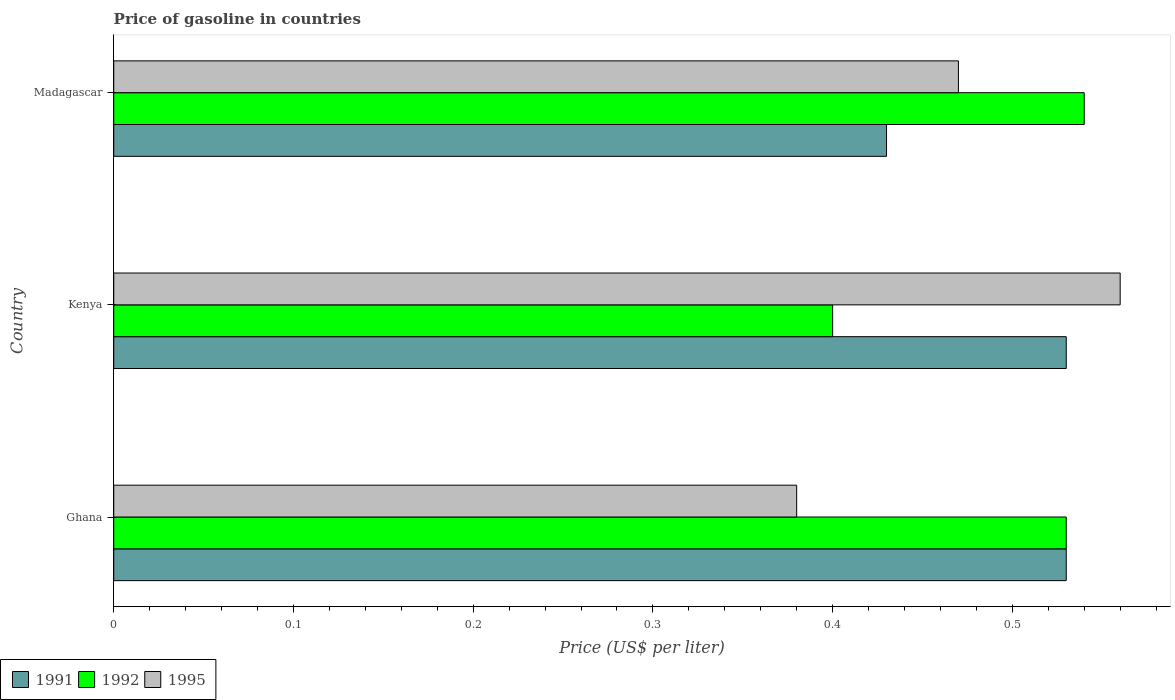Are the number of bars per tick equal to the number of legend labels?
Offer a very short reply. Yes. Are the number of bars on each tick of the Y-axis equal?
Make the answer very short. Yes. How many bars are there on the 2nd tick from the bottom?
Provide a short and direct response. 3. What is the label of the 3rd group of bars from the top?
Ensure brevity in your answer.  Ghana. In how many cases, is the number of bars for a given country not equal to the number of legend labels?
Offer a very short reply. 0. What is the price of gasoline in 1995 in Ghana?
Give a very brief answer. 0.38. Across all countries, what is the maximum price of gasoline in 1995?
Keep it short and to the point. 0.56. Across all countries, what is the minimum price of gasoline in 1992?
Your response must be concise. 0.4. In which country was the price of gasoline in 1991 maximum?
Provide a succinct answer. Ghana. What is the total price of gasoline in 1992 in the graph?
Provide a short and direct response. 1.47. What is the difference between the price of gasoline in 1995 in Ghana and that in Kenya?
Give a very brief answer. -0.18. What is the difference between the price of gasoline in 1995 in Ghana and the price of gasoline in 1991 in Madagascar?
Offer a very short reply. -0.05. What is the average price of gasoline in 1992 per country?
Ensure brevity in your answer.  0.49. What is the difference between the price of gasoline in 1992 and price of gasoline in 1995 in Madagascar?
Your response must be concise. 0.07. What is the ratio of the price of gasoline in 1995 in Ghana to that in Madagascar?
Ensure brevity in your answer.  0.81. Is the price of gasoline in 1991 in Ghana less than that in Madagascar?
Your answer should be very brief. No. What is the difference between the highest and the lowest price of gasoline in 1995?
Give a very brief answer. 0.18. Is the sum of the price of gasoline in 1991 in Ghana and Madagascar greater than the maximum price of gasoline in 1992 across all countries?
Keep it short and to the point. Yes. What does the 3rd bar from the bottom in Kenya represents?
Offer a terse response. 1995. Are all the bars in the graph horizontal?
Make the answer very short. Yes. How many countries are there in the graph?
Make the answer very short. 3. What is the difference between two consecutive major ticks on the X-axis?
Make the answer very short. 0.1. Are the values on the major ticks of X-axis written in scientific E-notation?
Provide a succinct answer. No. Does the graph contain grids?
Keep it short and to the point. No. How many legend labels are there?
Your answer should be very brief. 3. How are the legend labels stacked?
Give a very brief answer. Horizontal. What is the title of the graph?
Offer a terse response. Price of gasoline in countries. What is the label or title of the X-axis?
Your answer should be compact. Price (US$ per liter). What is the Price (US$ per liter) of 1991 in Ghana?
Ensure brevity in your answer.  0.53. What is the Price (US$ per liter) of 1992 in Ghana?
Make the answer very short. 0.53. What is the Price (US$ per liter) in 1995 in Ghana?
Keep it short and to the point. 0.38. What is the Price (US$ per liter) of 1991 in Kenya?
Provide a succinct answer. 0.53. What is the Price (US$ per liter) of 1992 in Kenya?
Your answer should be very brief. 0.4. What is the Price (US$ per liter) in 1995 in Kenya?
Your response must be concise. 0.56. What is the Price (US$ per liter) of 1991 in Madagascar?
Offer a very short reply. 0.43. What is the Price (US$ per liter) in 1992 in Madagascar?
Your answer should be very brief. 0.54. What is the Price (US$ per liter) of 1995 in Madagascar?
Your answer should be compact. 0.47. Across all countries, what is the maximum Price (US$ per liter) of 1991?
Your answer should be compact. 0.53. Across all countries, what is the maximum Price (US$ per liter) of 1992?
Make the answer very short. 0.54. Across all countries, what is the maximum Price (US$ per liter) in 1995?
Give a very brief answer. 0.56. Across all countries, what is the minimum Price (US$ per liter) of 1991?
Give a very brief answer. 0.43. Across all countries, what is the minimum Price (US$ per liter) of 1992?
Offer a very short reply. 0.4. Across all countries, what is the minimum Price (US$ per liter) in 1995?
Offer a very short reply. 0.38. What is the total Price (US$ per liter) of 1991 in the graph?
Your answer should be compact. 1.49. What is the total Price (US$ per liter) in 1992 in the graph?
Your answer should be compact. 1.47. What is the total Price (US$ per liter) in 1995 in the graph?
Provide a short and direct response. 1.41. What is the difference between the Price (US$ per liter) in 1992 in Ghana and that in Kenya?
Provide a succinct answer. 0.13. What is the difference between the Price (US$ per liter) of 1995 in Ghana and that in Kenya?
Offer a terse response. -0.18. What is the difference between the Price (US$ per liter) in 1992 in Ghana and that in Madagascar?
Your response must be concise. -0.01. What is the difference between the Price (US$ per liter) of 1995 in Ghana and that in Madagascar?
Your answer should be compact. -0.09. What is the difference between the Price (US$ per liter) of 1992 in Kenya and that in Madagascar?
Make the answer very short. -0.14. What is the difference between the Price (US$ per liter) of 1995 in Kenya and that in Madagascar?
Your answer should be compact. 0.09. What is the difference between the Price (US$ per liter) of 1991 in Ghana and the Price (US$ per liter) of 1992 in Kenya?
Your answer should be compact. 0.13. What is the difference between the Price (US$ per liter) of 1991 in Ghana and the Price (US$ per liter) of 1995 in Kenya?
Make the answer very short. -0.03. What is the difference between the Price (US$ per liter) of 1992 in Ghana and the Price (US$ per liter) of 1995 in Kenya?
Your answer should be compact. -0.03. What is the difference between the Price (US$ per liter) in 1991 in Ghana and the Price (US$ per liter) in 1992 in Madagascar?
Give a very brief answer. -0.01. What is the difference between the Price (US$ per liter) of 1991 in Ghana and the Price (US$ per liter) of 1995 in Madagascar?
Your response must be concise. 0.06. What is the difference between the Price (US$ per liter) of 1991 in Kenya and the Price (US$ per liter) of 1992 in Madagascar?
Keep it short and to the point. -0.01. What is the difference between the Price (US$ per liter) in 1991 in Kenya and the Price (US$ per liter) in 1995 in Madagascar?
Provide a short and direct response. 0.06. What is the difference between the Price (US$ per liter) in 1992 in Kenya and the Price (US$ per liter) in 1995 in Madagascar?
Your answer should be very brief. -0.07. What is the average Price (US$ per liter) of 1991 per country?
Your answer should be very brief. 0.5. What is the average Price (US$ per liter) in 1992 per country?
Your response must be concise. 0.49. What is the average Price (US$ per liter) of 1995 per country?
Ensure brevity in your answer.  0.47. What is the difference between the Price (US$ per liter) of 1991 and Price (US$ per liter) of 1992 in Ghana?
Offer a terse response. 0. What is the difference between the Price (US$ per liter) of 1991 and Price (US$ per liter) of 1995 in Ghana?
Provide a succinct answer. 0.15. What is the difference between the Price (US$ per liter) in 1992 and Price (US$ per liter) in 1995 in Ghana?
Offer a very short reply. 0.15. What is the difference between the Price (US$ per liter) in 1991 and Price (US$ per liter) in 1992 in Kenya?
Your response must be concise. 0.13. What is the difference between the Price (US$ per liter) of 1991 and Price (US$ per liter) of 1995 in Kenya?
Provide a short and direct response. -0.03. What is the difference between the Price (US$ per liter) of 1992 and Price (US$ per liter) of 1995 in Kenya?
Provide a short and direct response. -0.16. What is the difference between the Price (US$ per liter) in 1991 and Price (US$ per liter) in 1992 in Madagascar?
Your answer should be compact. -0.11. What is the difference between the Price (US$ per liter) of 1991 and Price (US$ per liter) of 1995 in Madagascar?
Your response must be concise. -0.04. What is the difference between the Price (US$ per liter) in 1992 and Price (US$ per liter) in 1995 in Madagascar?
Offer a terse response. 0.07. What is the ratio of the Price (US$ per liter) in 1991 in Ghana to that in Kenya?
Keep it short and to the point. 1. What is the ratio of the Price (US$ per liter) in 1992 in Ghana to that in Kenya?
Keep it short and to the point. 1.32. What is the ratio of the Price (US$ per liter) in 1995 in Ghana to that in Kenya?
Provide a succinct answer. 0.68. What is the ratio of the Price (US$ per liter) in 1991 in Ghana to that in Madagascar?
Ensure brevity in your answer.  1.23. What is the ratio of the Price (US$ per liter) of 1992 in Ghana to that in Madagascar?
Offer a terse response. 0.98. What is the ratio of the Price (US$ per liter) in 1995 in Ghana to that in Madagascar?
Your answer should be very brief. 0.81. What is the ratio of the Price (US$ per liter) of 1991 in Kenya to that in Madagascar?
Keep it short and to the point. 1.23. What is the ratio of the Price (US$ per liter) of 1992 in Kenya to that in Madagascar?
Offer a very short reply. 0.74. What is the ratio of the Price (US$ per liter) in 1995 in Kenya to that in Madagascar?
Give a very brief answer. 1.19. What is the difference between the highest and the second highest Price (US$ per liter) of 1991?
Offer a very short reply. 0. What is the difference between the highest and the second highest Price (US$ per liter) in 1995?
Offer a terse response. 0.09. What is the difference between the highest and the lowest Price (US$ per liter) of 1991?
Provide a succinct answer. 0.1. What is the difference between the highest and the lowest Price (US$ per liter) in 1992?
Your answer should be very brief. 0.14. What is the difference between the highest and the lowest Price (US$ per liter) of 1995?
Give a very brief answer. 0.18. 